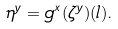Convert formula to latex. <formula><loc_0><loc_0><loc_500><loc_500>\eta ^ { y } = g ^ { x } ( \zeta ^ { y } ) ( l ) .</formula> 